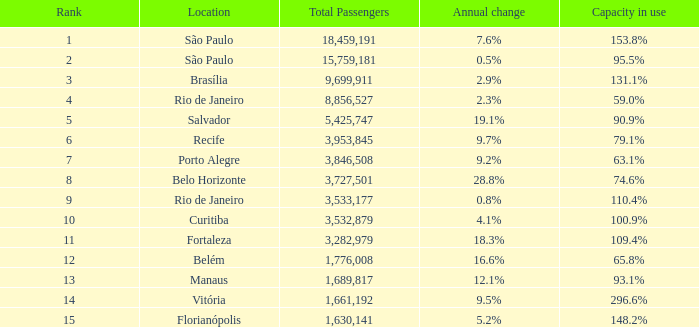What is the overall count of total passengers when the yearly variation is 2 0.0. 